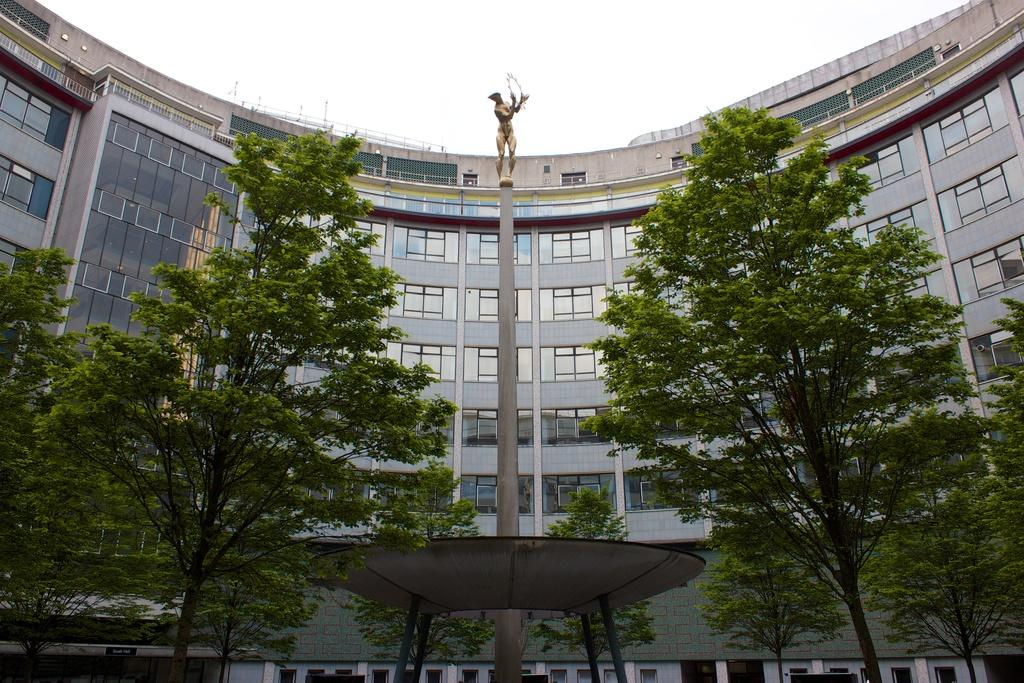What type of structure is visible in the image? There is a building in the image. What other natural elements can be seen in the image? There are plants, trees, and the sky visible in the image. Can you describe the statue in the image? There is a statue on a pole in the image. What is the unidentified object in the image? There is an object in the image, but its purpose or identity is not clear from the provided facts. What is the shocking news that the plants are discussing in the image? There is no indication in the image that the plants are discussing any news, shocking or otherwise. 